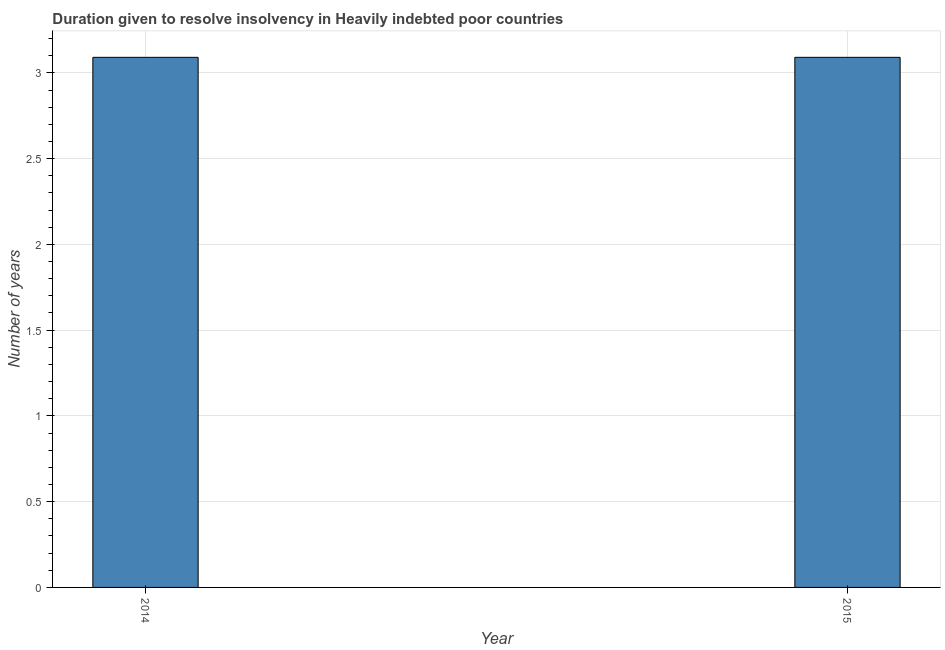What is the title of the graph?
Offer a very short reply. Duration given to resolve insolvency in Heavily indebted poor countries. What is the label or title of the Y-axis?
Offer a terse response. Number of years. What is the number of years to resolve insolvency in 2015?
Offer a very short reply. 3.09. Across all years, what is the maximum number of years to resolve insolvency?
Your answer should be very brief. 3.09. Across all years, what is the minimum number of years to resolve insolvency?
Your answer should be very brief. 3.09. What is the sum of the number of years to resolve insolvency?
Give a very brief answer. 6.18. What is the average number of years to resolve insolvency per year?
Provide a short and direct response. 3.09. What is the median number of years to resolve insolvency?
Keep it short and to the point. 3.09. In how many years, is the number of years to resolve insolvency greater than the average number of years to resolve insolvency taken over all years?
Provide a succinct answer. 0. How many bars are there?
Give a very brief answer. 2. Are all the bars in the graph horizontal?
Your answer should be compact. No. How many years are there in the graph?
Offer a terse response. 2. Are the values on the major ticks of Y-axis written in scientific E-notation?
Ensure brevity in your answer.  No. What is the Number of years in 2014?
Offer a very short reply. 3.09. What is the Number of years of 2015?
Keep it short and to the point. 3.09. What is the ratio of the Number of years in 2014 to that in 2015?
Provide a short and direct response. 1. 